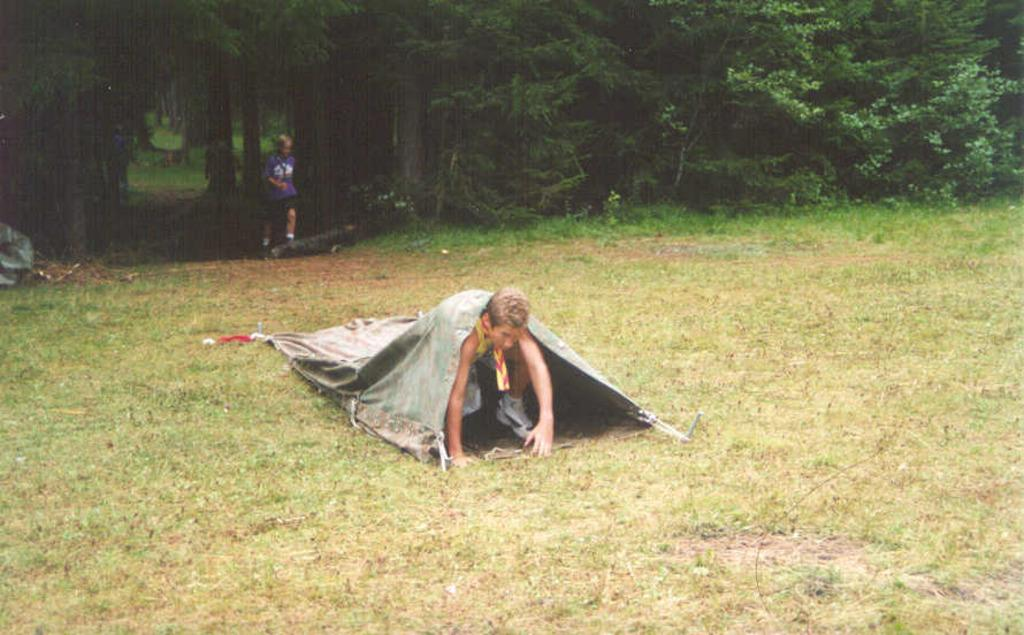Who is the main subject in the image? There is a person in the middle of the image. What is the person doing in the image? The person is trying to come out from a cloth. What can be seen in the background of the image? There are trees visible in the background of the image. Are there any other people in the image? Yes, there is another person in the background of the image. What type of pie is being served on the ground in the image? There is no pie or ground present in the image. What kind of jewel is the person wearing on their finger in the image? There is no jewel visible on any person's finger in the image. 